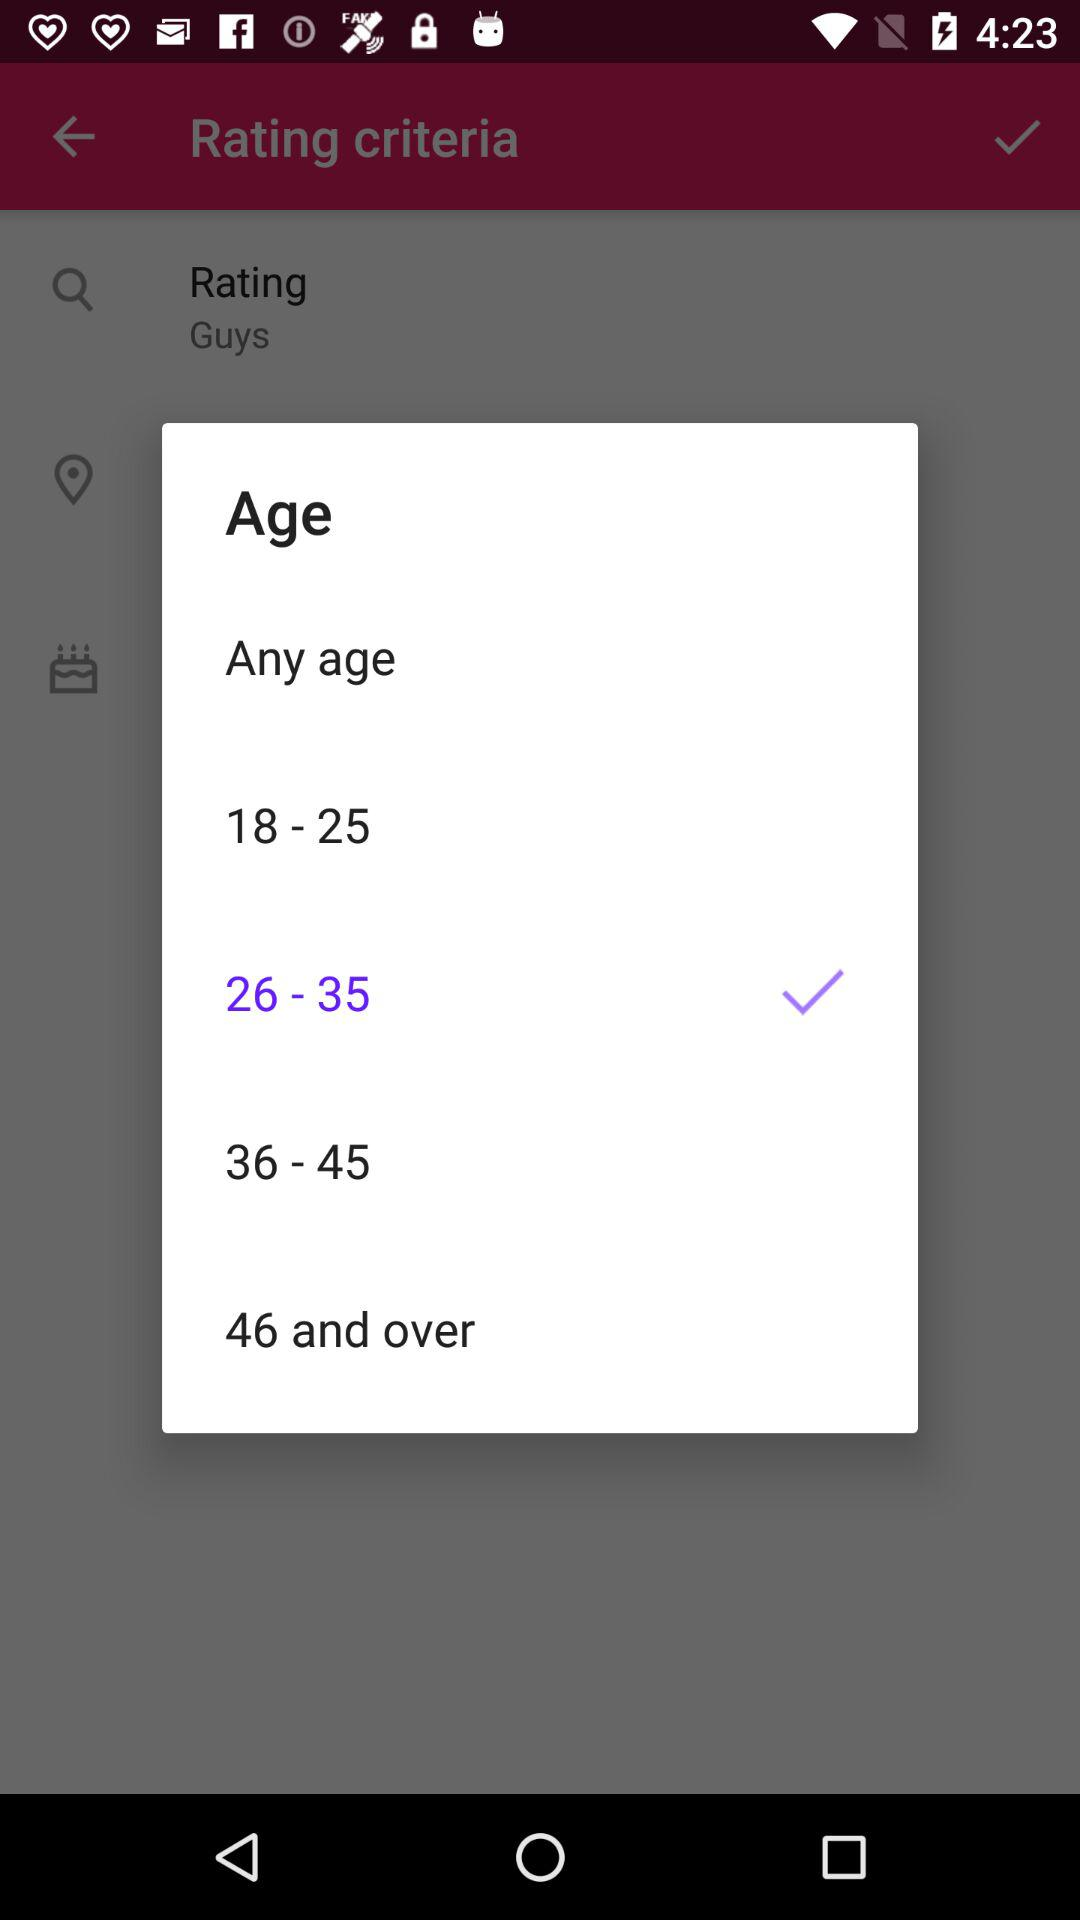Which option is selected? The selected option is "26 - 35". 